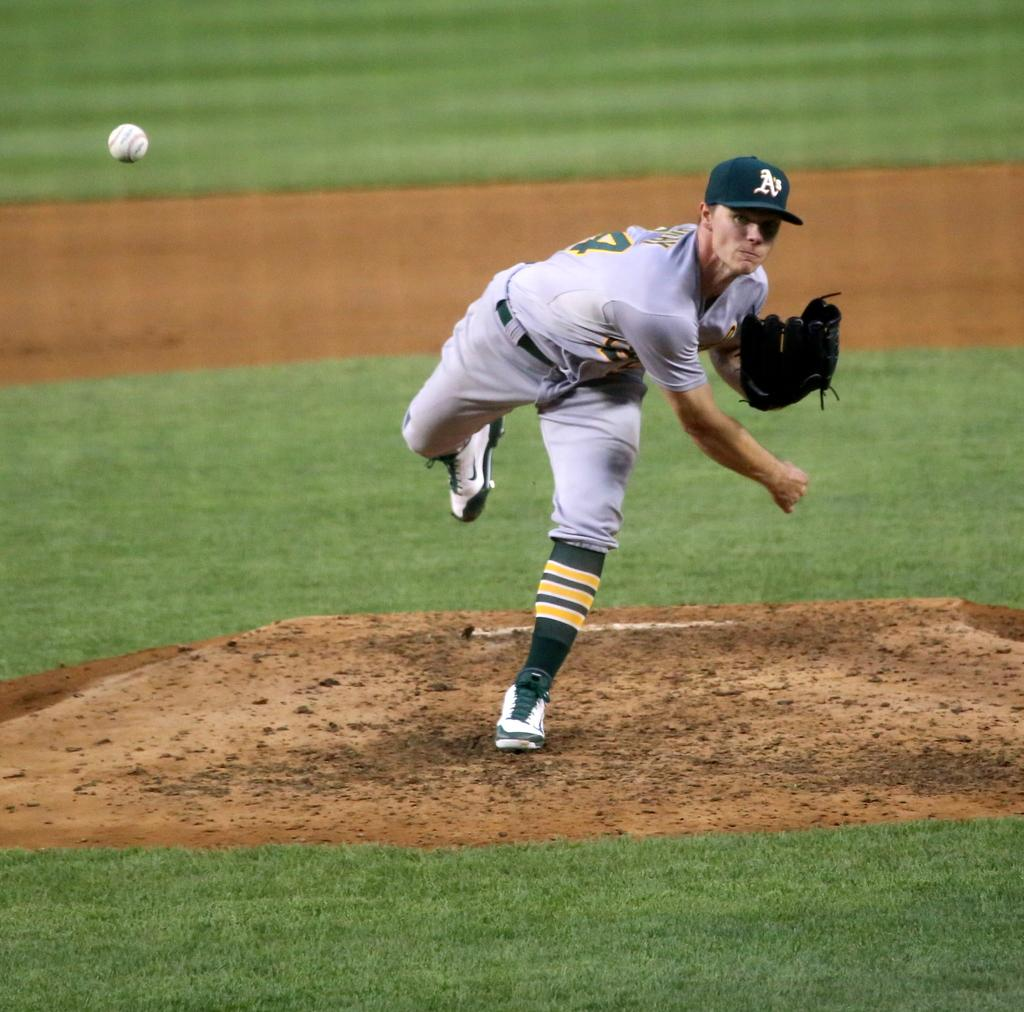<image>
Describe the image concisely. A pitcher for the A's baseball team throws the ball from the mound. 